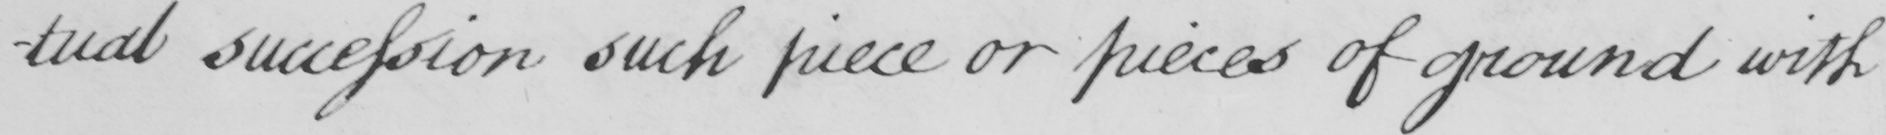What text is written in this handwritten line? -tual succession such piece or pieces of ground with 